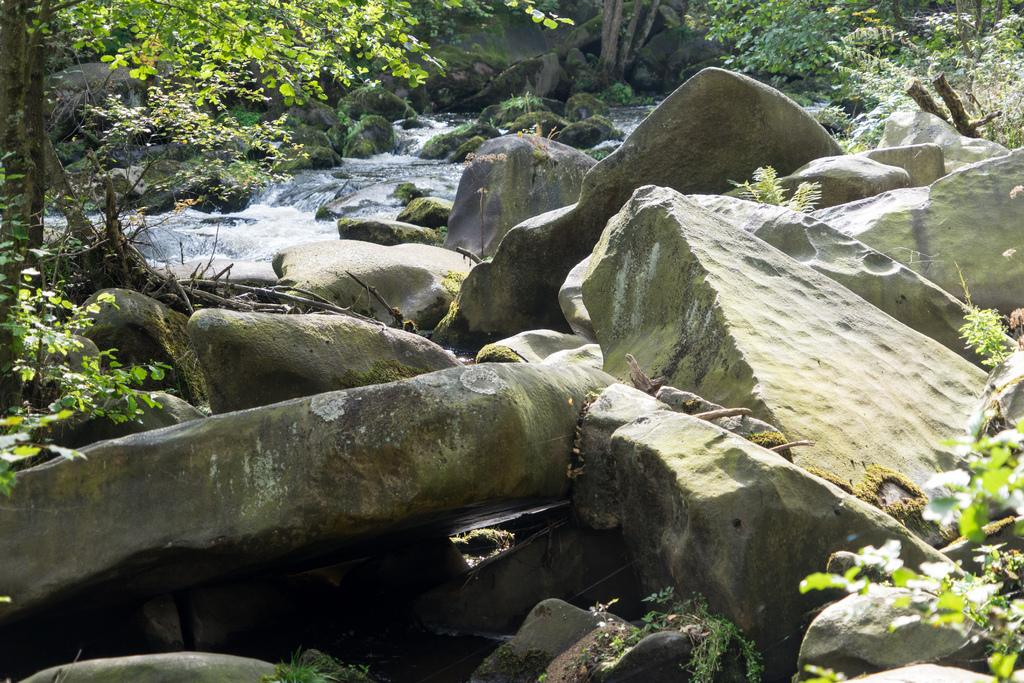What type of natural elements can be seen in the image? There are rocks and trees in the image. What is located in the middle of the rocks? There is water in the middle of the rocks. Is there any sign of plant life on the rocks? Yes, there is algae on the rocks. How many geese are standing on the rocks in the image? There are no geese present in the image. What type of shoes can be seen on the rocks in the image? There are no shoes present in the image. 